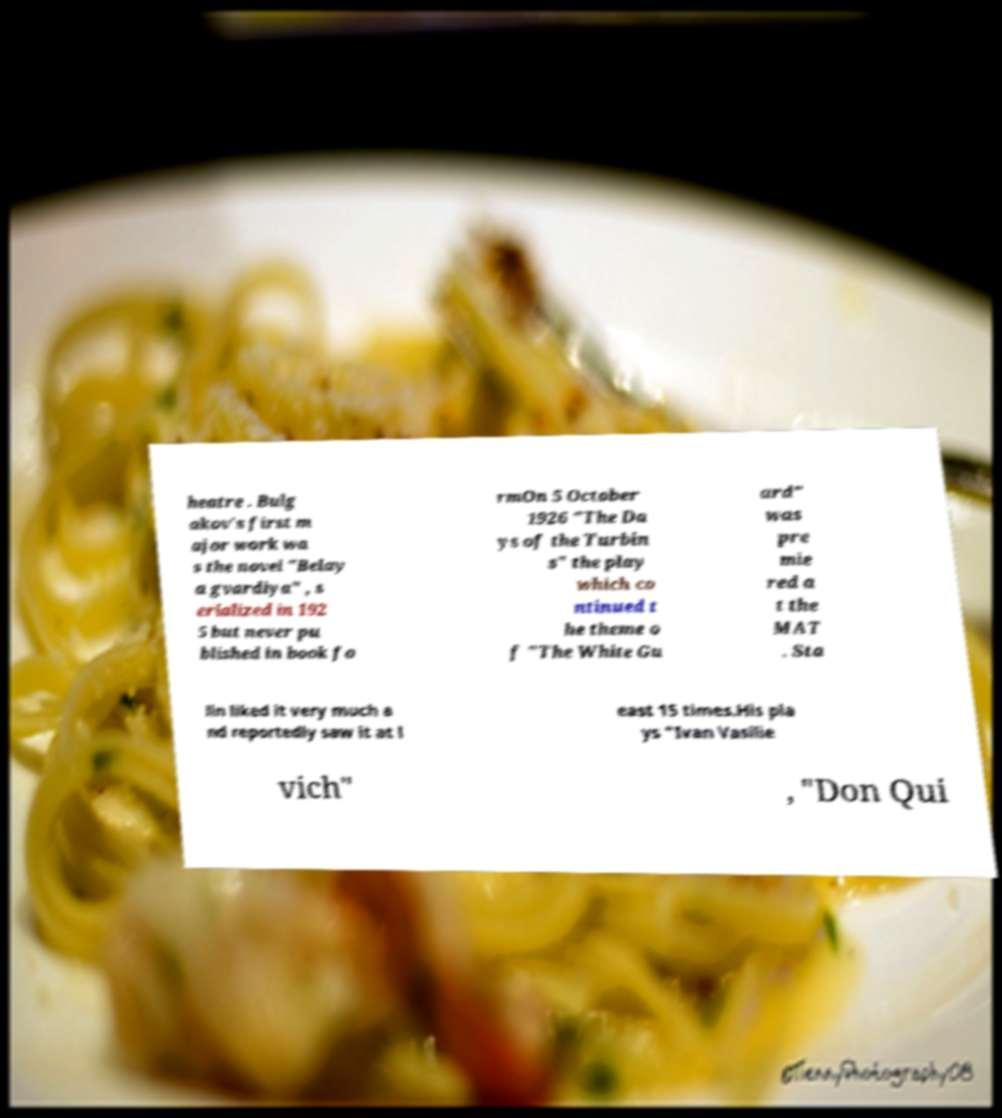Please read and relay the text visible in this image. What does it say? heatre . Bulg akov's first m ajor work wa s the novel "Belay a gvardiya" , s erialized in 192 5 but never pu blished in book fo rmOn 5 October 1926 "The Da ys of the Turbin s" the play which co ntinued t he theme o f "The White Gu ard" was pre mie red a t the MAT . Sta lin liked it very much a nd reportedly saw it at l east 15 times.His pla ys "Ivan Vasilie vich" , "Don Qui 